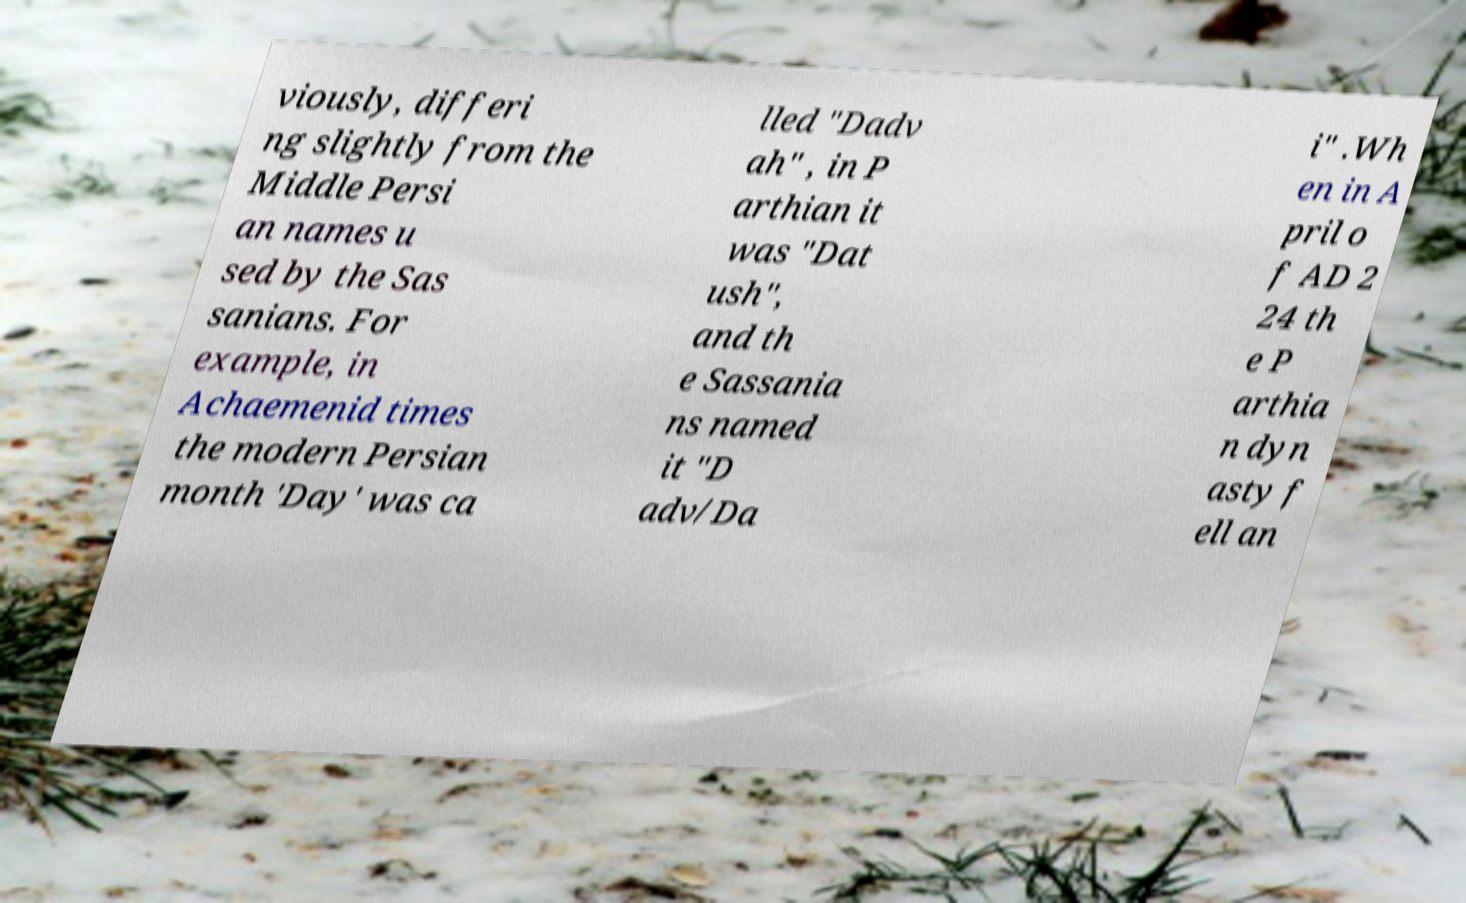Can you accurately transcribe the text from the provided image for me? viously, differi ng slightly from the Middle Persi an names u sed by the Sas sanians. For example, in Achaemenid times the modern Persian month 'Day' was ca lled "Dadv ah" , in P arthian it was "Dat ush", and th e Sassania ns named it "D adv/Da i" .Wh en in A pril o f AD 2 24 th e P arthia n dyn asty f ell an 